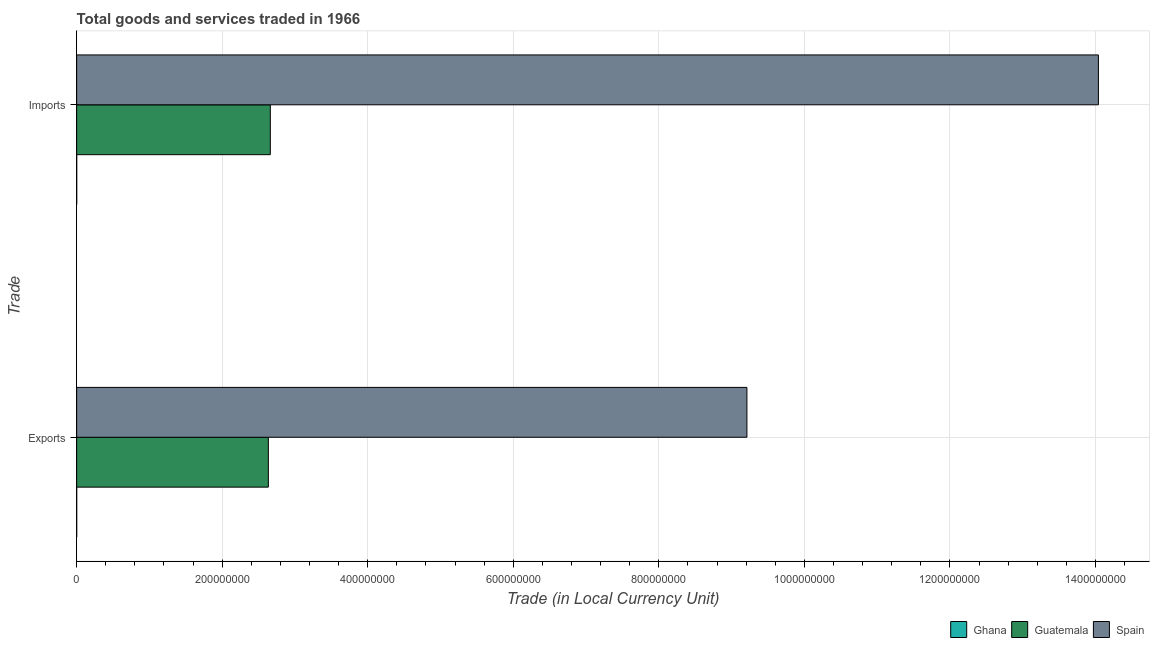How many groups of bars are there?
Your answer should be very brief. 2. Are the number of bars per tick equal to the number of legend labels?
Offer a terse response. Yes. Are the number of bars on each tick of the Y-axis equal?
Your response must be concise. Yes. What is the label of the 2nd group of bars from the top?
Your response must be concise. Exports. What is the imports of goods and services in Guatemala?
Make the answer very short. 2.66e+08. Across all countries, what is the maximum imports of goods and services?
Make the answer very short. 1.40e+09. Across all countries, what is the minimum export of goods and services?
Make the answer very short. 2.22e+04. In which country was the imports of goods and services maximum?
Offer a terse response. Spain. In which country was the export of goods and services minimum?
Give a very brief answer. Ghana. What is the total export of goods and services in the graph?
Offer a very short reply. 1.18e+09. What is the difference between the imports of goods and services in Guatemala and that in Spain?
Keep it short and to the point. -1.14e+09. What is the difference between the imports of goods and services in Spain and the export of goods and services in Ghana?
Your answer should be very brief. 1.40e+09. What is the average imports of goods and services per country?
Your response must be concise. 5.57e+08. What is the difference between the imports of goods and services and export of goods and services in Ghana?
Your answer should be very brief. 7600. What is the ratio of the imports of goods and services in Spain to that in Ghana?
Make the answer very short. 4.71e+04. Is the export of goods and services in Spain less than that in Ghana?
Your answer should be very brief. No. What does the 1st bar from the bottom in Exports represents?
Give a very brief answer. Ghana. How many countries are there in the graph?
Provide a succinct answer. 3. Are the values on the major ticks of X-axis written in scientific E-notation?
Provide a succinct answer. No. How many legend labels are there?
Keep it short and to the point. 3. What is the title of the graph?
Keep it short and to the point. Total goods and services traded in 1966. Does "Ethiopia" appear as one of the legend labels in the graph?
Give a very brief answer. No. What is the label or title of the X-axis?
Offer a very short reply. Trade (in Local Currency Unit). What is the label or title of the Y-axis?
Offer a very short reply. Trade. What is the Trade (in Local Currency Unit) in Ghana in Exports?
Keep it short and to the point. 2.22e+04. What is the Trade (in Local Currency Unit) in Guatemala in Exports?
Make the answer very short. 2.63e+08. What is the Trade (in Local Currency Unit) of Spain in Exports?
Make the answer very short. 9.21e+08. What is the Trade (in Local Currency Unit) of Ghana in Imports?
Provide a short and direct response. 2.98e+04. What is the Trade (in Local Currency Unit) of Guatemala in Imports?
Provide a short and direct response. 2.66e+08. What is the Trade (in Local Currency Unit) in Spain in Imports?
Your response must be concise. 1.40e+09. Across all Trade, what is the maximum Trade (in Local Currency Unit) in Ghana?
Provide a short and direct response. 2.98e+04. Across all Trade, what is the maximum Trade (in Local Currency Unit) in Guatemala?
Ensure brevity in your answer.  2.66e+08. Across all Trade, what is the maximum Trade (in Local Currency Unit) in Spain?
Your answer should be compact. 1.40e+09. Across all Trade, what is the minimum Trade (in Local Currency Unit) of Ghana?
Your answer should be very brief. 2.22e+04. Across all Trade, what is the minimum Trade (in Local Currency Unit) of Guatemala?
Your answer should be very brief. 2.63e+08. Across all Trade, what is the minimum Trade (in Local Currency Unit) in Spain?
Your answer should be compact. 9.21e+08. What is the total Trade (in Local Currency Unit) in Ghana in the graph?
Ensure brevity in your answer.  5.20e+04. What is the total Trade (in Local Currency Unit) in Guatemala in the graph?
Provide a short and direct response. 5.30e+08. What is the total Trade (in Local Currency Unit) in Spain in the graph?
Your response must be concise. 2.33e+09. What is the difference between the Trade (in Local Currency Unit) in Ghana in Exports and that in Imports?
Offer a very short reply. -7600. What is the difference between the Trade (in Local Currency Unit) of Guatemala in Exports and that in Imports?
Give a very brief answer. -2.70e+06. What is the difference between the Trade (in Local Currency Unit) in Spain in Exports and that in Imports?
Offer a terse response. -4.83e+08. What is the difference between the Trade (in Local Currency Unit) in Ghana in Exports and the Trade (in Local Currency Unit) in Guatemala in Imports?
Provide a short and direct response. -2.66e+08. What is the difference between the Trade (in Local Currency Unit) in Ghana in Exports and the Trade (in Local Currency Unit) in Spain in Imports?
Ensure brevity in your answer.  -1.40e+09. What is the difference between the Trade (in Local Currency Unit) of Guatemala in Exports and the Trade (in Local Currency Unit) of Spain in Imports?
Give a very brief answer. -1.14e+09. What is the average Trade (in Local Currency Unit) in Ghana per Trade?
Give a very brief answer. 2.60e+04. What is the average Trade (in Local Currency Unit) in Guatemala per Trade?
Ensure brevity in your answer.  2.65e+08. What is the average Trade (in Local Currency Unit) in Spain per Trade?
Ensure brevity in your answer.  1.16e+09. What is the difference between the Trade (in Local Currency Unit) of Ghana and Trade (in Local Currency Unit) of Guatemala in Exports?
Ensure brevity in your answer.  -2.63e+08. What is the difference between the Trade (in Local Currency Unit) of Ghana and Trade (in Local Currency Unit) of Spain in Exports?
Make the answer very short. -9.21e+08. What is the difference between the Trade (in Local Currency Unit) in Guatemala and Trade (in Local Currency Unit) in Spain in Exports?
Provide a succinct answer. -6.58e+08. What is the difference between the Trade (in Local Currency Unit) in Ghana and Trade (in Local Currency Unit) in Guatemala in Imports?
Offer a very short reply. -2.66e+08. What is the difference between the Trade (in Local Currency Unit) of Ghana and Trade (in Local Currency Unit) of Spain in Imports?
Offer a very short reply. -1.40e+09. What is the difference between the Trade (in Local Currency Unit) of Guatemala and Trade (in Local Currency Unit) of Spain in Imports?
Your answer should be very brief. -1.14e+09. What is the ratio of the Trade (in Local Currency Unit) of Ghana in Exports to that in Imports?
Keep it short and to the point. 0.74. What is the ratio of the Trade (in Local Currency Unit) of Guatemala in Exports to that in Imports?
Offer a terse response. 0.99. What is the ratio of the Trade (in Local Currency Unit) in Spain in Exports to that in Imports?
Make the answer very short. 0.66. What is the difference between the highest and the second highest Trade (in Local Currency Unit) in Ghana?
Provide a short and direct response. 7600. What is the difference between the highest and the second highest Trade (in Local Currency Unit) of Guatemala?
Your response must be concise. 2.70e+06. What is the difference between the highest and the second highest Trade (in Local Currency Unit) in Spain?
Offer a terse response. 4.83e+08. What is the difference between the highest and the lowest Trade (in Local Currency Unit) of Ghana?
Your answer should be very brief. 7600. What is the difference between the highest and the lowest Trade (in Local Currency Unit) in Guatemala?
Provide a succinct answer. 2.70e+06. What is the difference between the highest and the lowest Trade (in Local Currency Unit) of Spain?
Make the answer very short. 4.83e+08. 